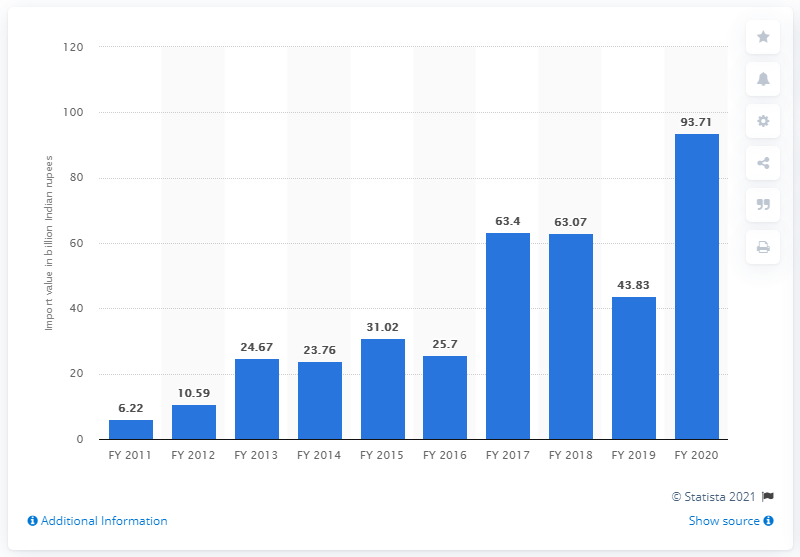Give some essential details in this illustration. In the fiscal year 2020, India imported goods worth 93.71 billion Indian rupees. In 2011, the import value of cotton was 6.22. 